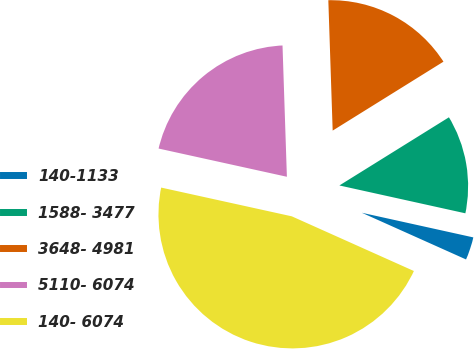<chart> <loc_0><loc_0><loc_500><loc_500><pie_chart><fcel>140-1133<fcel>1588- 3477<fcel>3648- 4981<fcel>5110- 6074<fcel>140- 6074<nl><fcel>3.24%<fcel>12.32%<fcel>16.67%<fcel>21.02%<fcel>46.74%<nl></chart> 